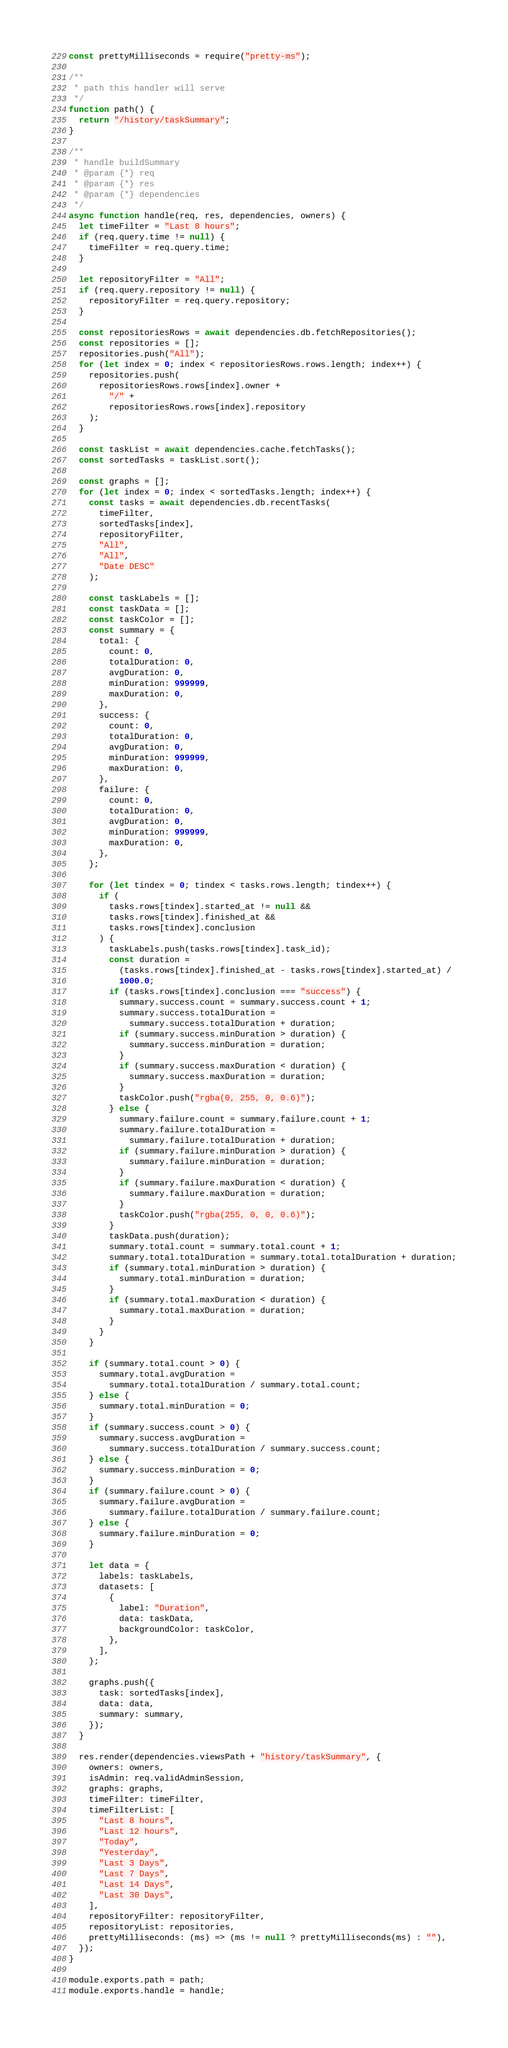<code> <loc_0><loc_0><loc_500><loc_500><_JavaScript_>const prettyMilliseconds = require("pretty-ms");

/**
 * path this handler will serve
 */
function path() {
  return "/history/taskSummary";
}

/**
 * handle buildSummary
 * @param {*} req
 * @param {*} res
 * @param {*} dependencies
 */
async function handle(req, res, dependencies, owners) {
  let timeFilter = "Last 8 hours";
  if (req.query.time != null) {
    timeFilter = req.query.time;
  }

  let repositoryFilter = "All";
  if (req.query.repository != null) {
    repositoryFilter = req.query.repository;
  }

  const repositoriesRows = await dependencies.db.fetchRepositories();
  const repositories = [];
  repositories.push("All");
  for (let index = 0; index < repositoriesRows.rows.length; index++) {
    repositories.push(
      repositoriesRows.rows[index].owner +
        "/" +
        repositoriesRows.rows[index].repository
    );
  }

  const taskList = await dependencies.cache.fetchTasks();
  const sortedTasks = taskList.sort();

  const graphs = [];
  for (let index = 0; index < sortedTasks.length; index++) {
    const tasks = await dependencies.db.recentTasks(
      timeFilter,
      sortedTasks[index],
      repositoryFilter,
      "All",
      "All",
      "Date DESC"
    );

    const taskLabels = [];
    const taskData = [];
    const taskColor = [];
    const summary = {
      total: {
        count: 0,
        totalDuration: 0,
        avgDuration: 0,
        minDuration: 999999,
        maxDuration: 0,
      },
      success: {
        count: 0,
        totalDuration: 0,
        avgDuration: 0,
        minDuration: 999999,
        maxDuration: 0,
      },
      failure: {
        count: 0,
        totalDuration: 0,
        avgDuration: 0,
        minDuration: 999999,
        maxDuration: 0,
      },
    };

    for (let tindex = 0; tindex < tasks.rows.length; tindex++) {
      if (
        tasks.rows[tindex].started_at != null &&
        tasks.rows[tindex].finished_at &&
        tasks.rows[tindex].conclusion
      ) {
        taskLabels.push(tasks.rows[tindex].task_id);
        const duration =
          (tasks.rows[tindex].finished_at - tasks.rows[tindex].started_at) /
          1000.0;
        if (tasks.rows[tindex].conclusion === "success") {
          summary.success.count = summary.success.count + 1;
          summary.success.totalDuration =
            summary.success.totalDuration + duration;
          if (summary.success.minDuration > duration) {
            summary.success.minDuration = duration;
          }
          if (summary.success.maxDuration < duration) {
            summary.success.maxDuration = duration;
          }
          taskColor.push("rgba(0, 255, 0, 0.6)");
        } else {
          summary.failure.count = summary.failure.count + 1;
          summary.failure.totalDuration =
            summary.failure.totalDuration + duration;
          if (summary.failure.minDuration > duration) {
            summary.failure.minDuration = duration;
          }
          if (summary.failure.maxDuration < duration) {
            summary.failure.maxDuration = duration;
          }
          taskColor.push("rgba(255, 0, 0, 0.6)");
        }
        taskData.push(duration);
        summary.total.count = summary.total.count + 1;
        summary.total.totalDuration = summary.total.totalDuration + duration;
        if (summary.total.minDuration > duration) {
          summary.total.minDuration = duration;
        }
        if (summary.total.maxDuration < duration) {
          summary.total.maxDuration = duration;
        }
      }
    }

    if (summary.total.count > 0) {
      summary.total.avgDuration =
        summary.total.totalDuration / summary.total.count;
    } else {
      summary.total.minDuration = 0;
    }
    if (summary.success.count > 0) {
      summary.success.avgDuration =
        summary.success.totalDuration / summary.success.count;
    } else {
      summary.success.minDuration = 0;
    }
    if (summary.failure.count > 0) {
      summary.failure.avgDuration =
        summary.failure.totalDuration / summary.failure.count;
    } else {
      summary.failure.minDuration = 0;
    }

    let data = {
      labels: taskLabels,
      datasets: [
        {
          label: "Duration",
          data: taskData,
          backgroundColor: taskColor,
        },
      ],
    };

    graphs.push({
      task: sortedTasks[index],
      data: data,
      summary: summary,
    });
  }

  res.render(dependencies.viewsPath + "history/taskSummary", {
    owners: owners,
    isAdmin: req.validAdminSession,
    graphs: graphs,
    timeFilter: timeFilter,
    timeFilterList: [
      "Last 8 hours",
      "Last 12 hours",
      "Today",
      "Yesterday",
      "Last 3 Days",
      "Last 7 Days",
      "Last 14 Days",
      "Last 30 Days",
    ],
    repositoryFilter: repositoryFilter,
    repositoryList: repositories,
    prettyMilliseconds: (ms) => (ms != null ? prettyMilliseconds(ms) : ""),
  });
}

module.exports.path = path;
module.exports.handle = handle;
</code> 